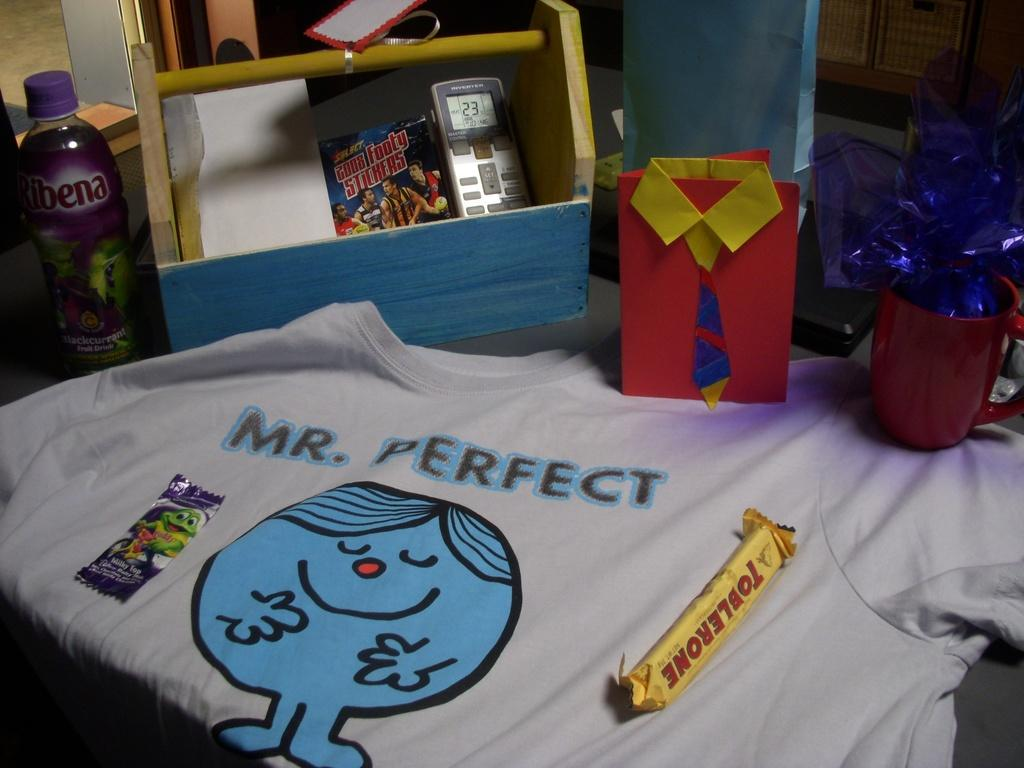<image>
Summarize the visual content of the image. A t-shirt with a blue character on it that says Mr. Perfect. 